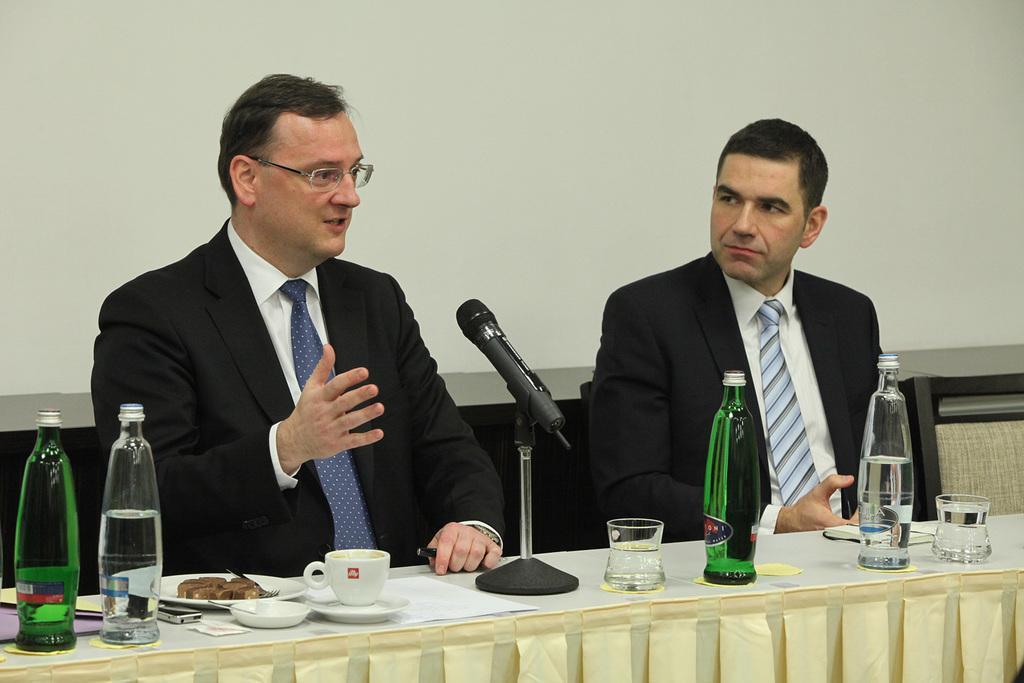In one or two sentences, can you explain what this image depicts? Here in this picture we can see two men, who are wearing suit are sitting on chairs with table in front of them having bottles, glasses, cups and plates present on it and the person on the left side is speaking something in the microphone present on the table. 